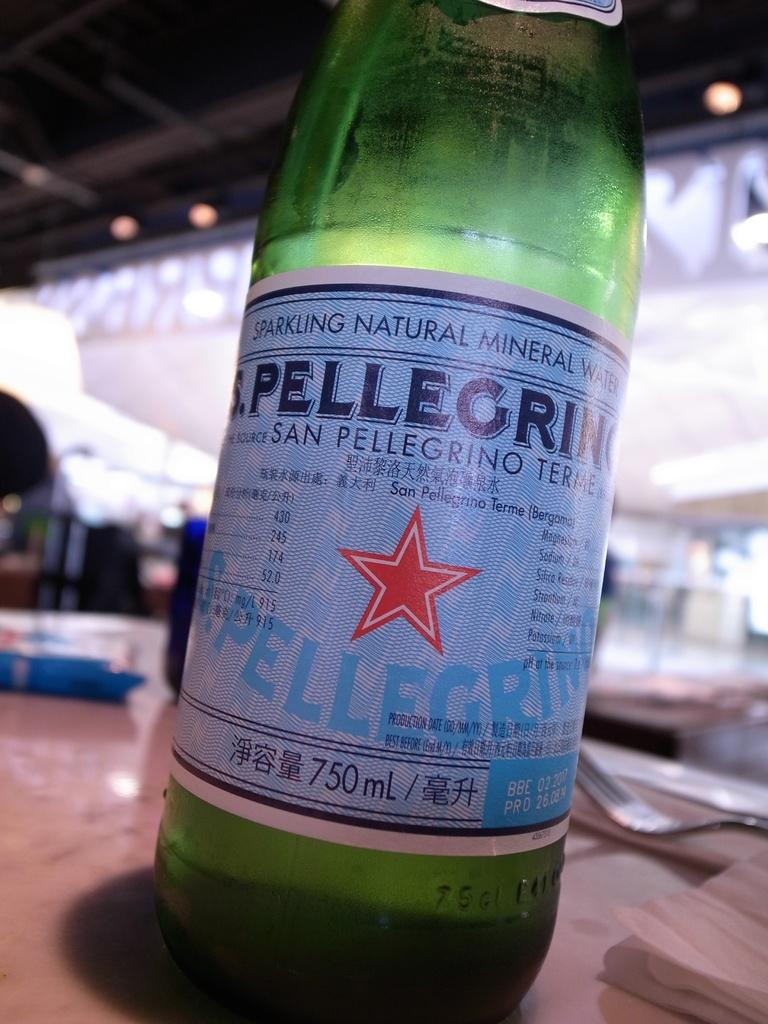<image>
Relay a brief, clear account of the picture shown. Beer bottle which says it is 750 ML inside. 